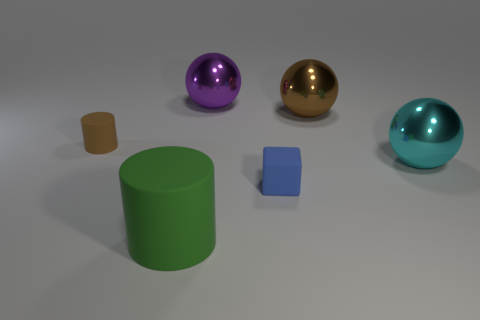Add 4 small yellow objects. How many objects exist? 10 Subtract all cylinders. How many objects are left? 4 Subtract all gray spheres. Subtract all spheres. How many objects are left? 3 Add 6 large brown spheres. How many large brown spheres are left? 7 Add 4 blue matte cubes. How many blue matte cubes exist? 5 Subtract 0 gray blocks. How many objects are left? 6 